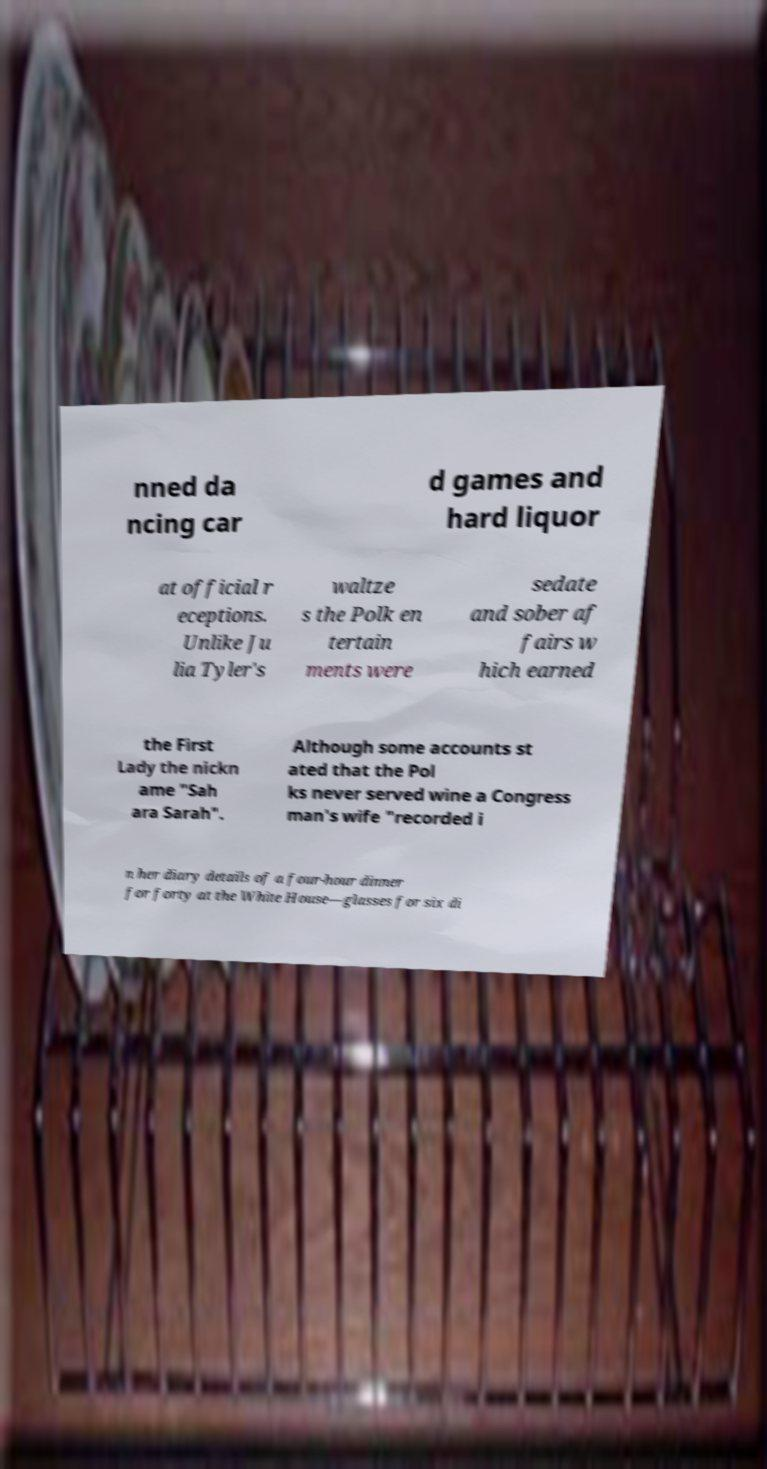For documentation purposes, I need the text within this image transcribed. Could you provide that? nned da ncing car d games and hard liquor at official r eceptions. Unlike Ju lia Tyler's waltze s the Polk en tertain ments were sedate and sober af fairs w hich earned the First Lady the nickn ame "Sah ara Sarah". Although some accounts st ated that the Pol ks never served wine a Congress man's wife "recorded i n her diary details of a four-hour dinner for forty at the White House—glasses for six di 